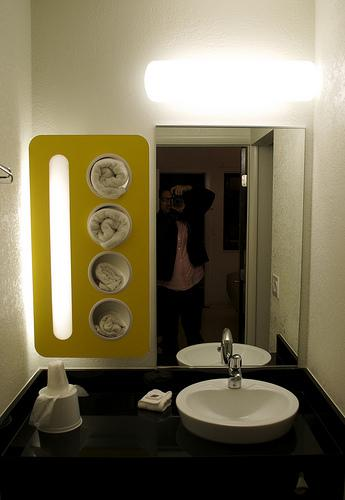Question: where was the picture taken?
Choices:
A. Patio.
B. Den.
C. Bathroom.
D. Bedroom.
Answer with the letter. Answer: C Question: who took the picture?
Choices:
A. A woman.
B. A child.
C. A man.
D. A photographer.
Answer with the letter. Answer: C 